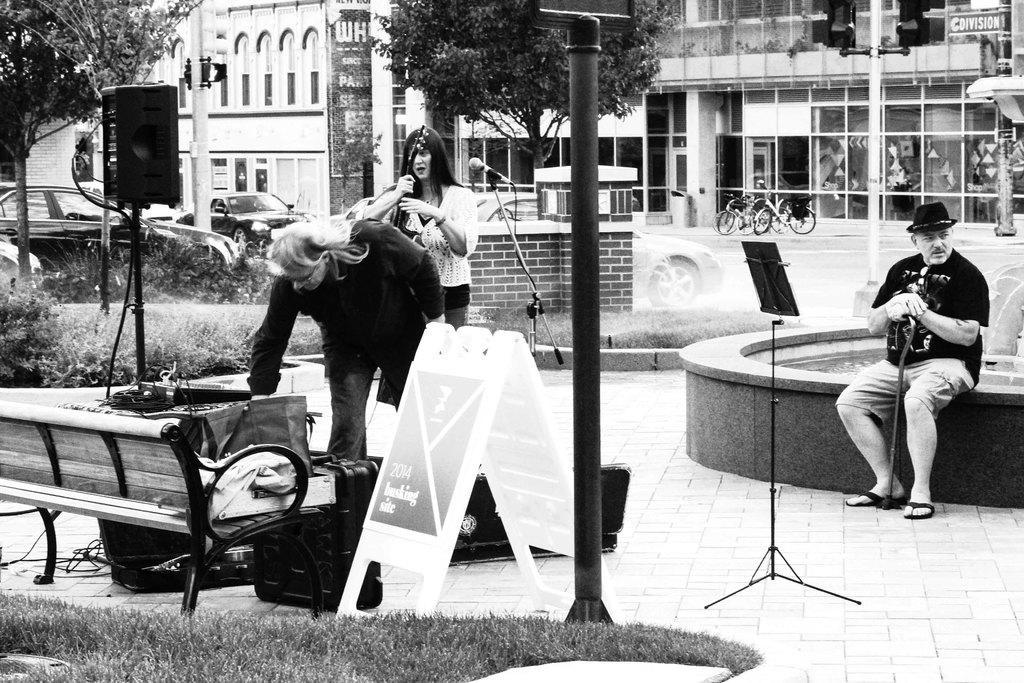In one or two sentences, can you explain what this image depicts? In this picture we can see the grass, bench, board, mic, stand, speaker, box, plants, trees, bicycles, cars, fountain and some objects and two people are standing and a man wore a cap and holding a stick with his hands and sitting and in the background we can see buildings. 